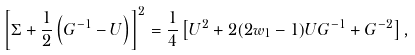<formula> <loc_0><loc_0><loc_500><loc_500>\left [ \Sigma + \frac { 1 } { 2 } \left ( G ^ { - 1 } - U \right ) \right ] ^ { 2 } = \frac { 1 } { 4 } \left [ U ^ { 2 } + 2 ( 2 w _ { 1 } - 1 ) U G ^ { - 1 } + G ^ { - 2 } \right ] ,</formula> 